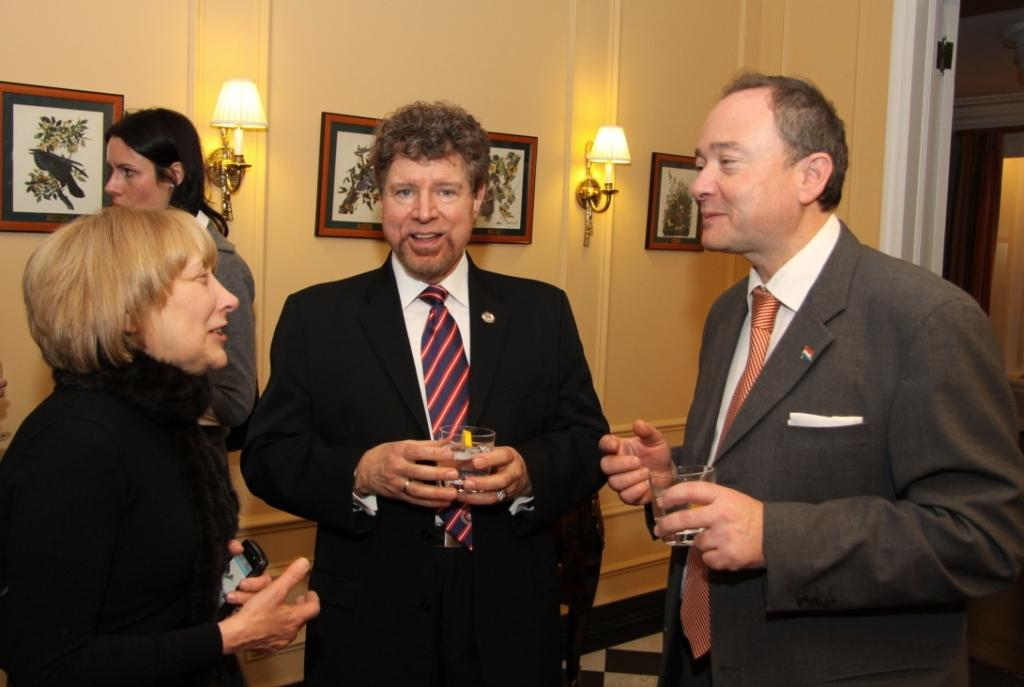How many people are in the image? There are two women and two men in the image. What are the men holding in the image? The men are holding glasses. What is the woman on the left side holding? The woman on the left side is holding a mobile. What can be seen in the background of the image? There is a wall in the background of the image, which has photo frames and lamps. How many hens are visible on the wall in the image? There are no hens visible on the wall in the image; the wall has photo frames and lamps. What type of twig is being used as a decoration in the image? There is no twig present in the image; the wall has photo frames and lamps as decorations. 